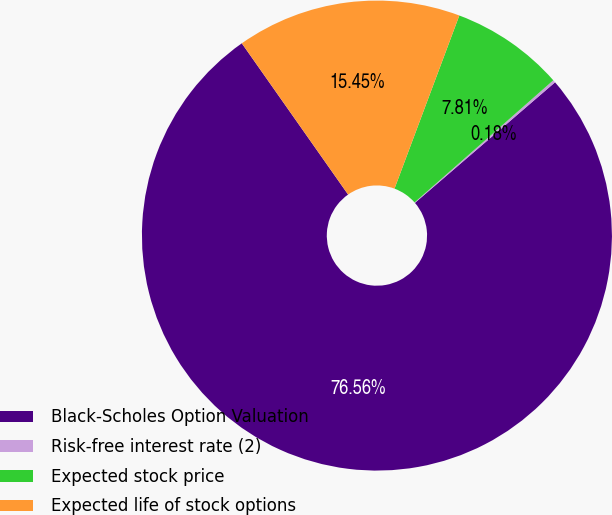Convert chart. <chart><loc_0><loc_0><loc_500><loc_500><pie_chart><fcel>Black-Scholes Option Valuation<fcel>Risk-free interest rate (2)<fcel>Expected stock price<fcel>Expected life of stock options<nl><fcel>76.56%<fcel>0.18%<fcel>7.81%<fcel>15.45%<nl></chart> 